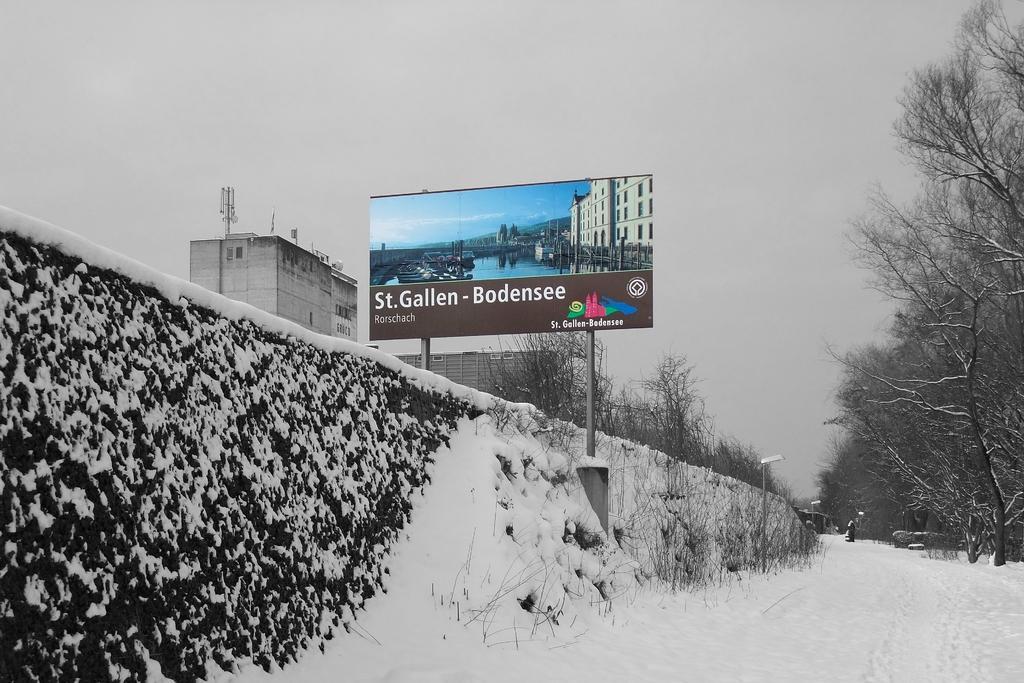Please provide a concise description of this image. In this picture we can see a hoarding, wall, snow, trees, buildings, light poles and some objects and in the background we can see the sky. 